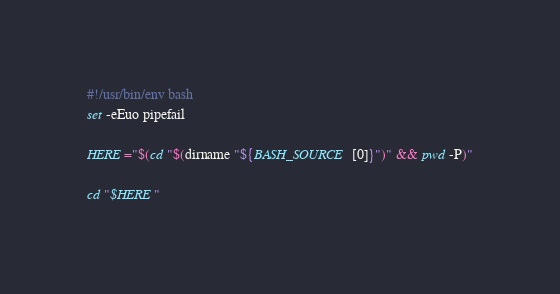Convert code to text. <code><loc_0><loc_0><loc_500><loc_500><_Bash_>#!/usr/bin/env bash
set -eEuo pipefail

HERE="$(cd "$(dirname "${BASH_SOURCE[0]}")" && pwd -P)"

cd "$HERE"
</code> 